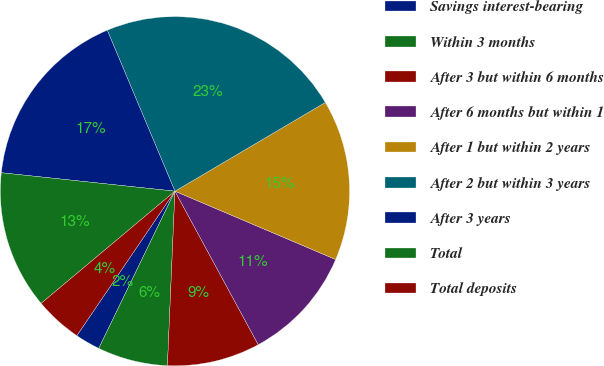<chart> <loc_0><loc_0><loc_500><loc_500><pie_chart><fcel>Savings interest-bearing<fcel>Within 3 months<fcel>After 3 but within 6 months<fcel>After 6 months but within 1<fcel>After 1 but within 2 years<fcel>After 2 but within 3 years<fcel>After 3 years<fcel>Total<fcel>Total deposits<nl><fcel>2.31%<fcel>6.5%<fcel>8.6%<fcel>10.69%<fcel>14.88%<fcel>22.85%<fcel>16.98%<fcel>12.79%<fcel>4.4%<nl></chart> 